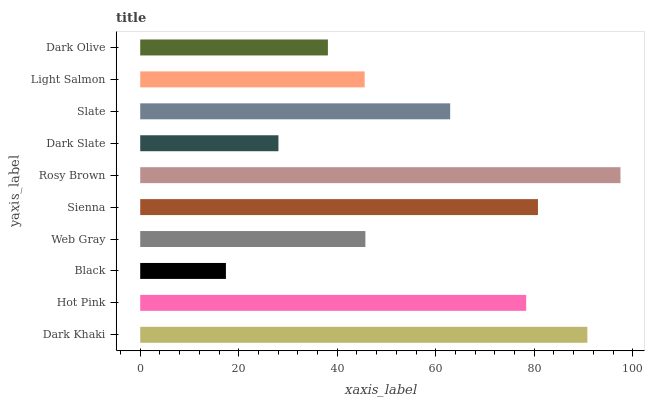Is Black the minimum?
Answer yes or no. Yes. Is Rosy Brown the maximum?
Answer yes or no. Yes. Is Hot Pink the minimum?
Answer yes or no. No. Is Hot Pink the maximum?
Answer yes or no. No. Is Dark Khaki greater than Hot Pink?
Answer yes or no. Yes. Is Hot Pink less than Dark Khaki?
Answer yes or no. Yes. Is Hot Pink greater than Dark Khaki?
Answer yes or no. No. Is Dark Khaki less than Hot Pink?
Answer yes or no. No. Is Slate the high median?
Answer yes or no. Yes. Is Web Gray the low median?
Answer yes or no. Yes. Is Light Salmon the high median?
Answer yes or no. No. Is Sienna the low median?
Answer yes or no. No. 